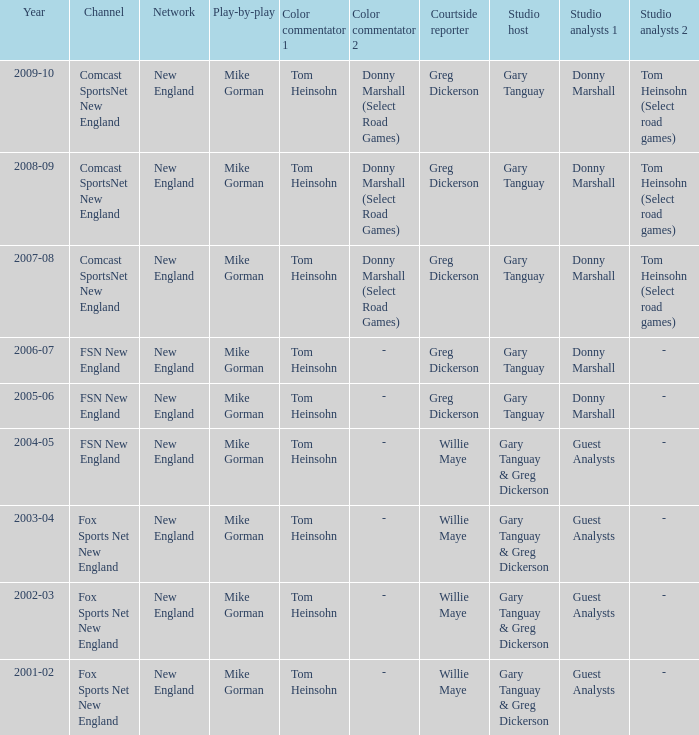Who is the courtside reporter for the year 2009-10? Greg Dickerson. 